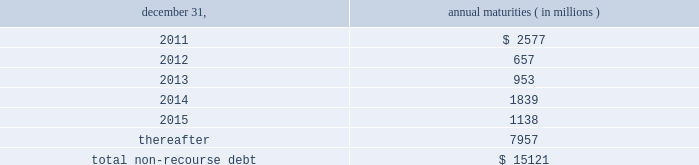The aes corporation notes to consolidated financial statements 2014 ( continued ) december 31 , 2010 , 2009 , and 2008 ( 3 ) multilateral loans include loans funded and guaranteed by bilaterals , multilaterals , development banks and other similar institutions .
( 4 ) non-recourse debt of $ 708 million as of december 31 , 2009 was excluded from non-recourse debt and included in current and long-term liabilities of held for sale and discontinued businesses in the accompanying consolidated balance sheets .
Non-recourse debt as of december 31 , 2010 is scheduled to reach maturity as set forth in the table below : december 31 , annual maturities ( in millions ) .
As of december 31 , 2010 , aes subsidiaries with facilities under construction had a total of approximately $ 432 million of committed but unused credit facilities available to fund construction and other related costs .
Excluding these facilities under construction , aes subsidiaries had approximately $ 893 million in a number of available but unused committed revolving credit lines to support their working capital , debt service reserves and other business needs .
These credit lines can be used in one or more of the following ways : solely for borrowings ; solely for letters of credit ; or a combination of these uses .
The weighted average interest rate on borrowings from these facilities was 3.24% ( 3.24 % ) at december 31 , 2010 .
Non-recourse debt covenants , restrictions and defaults the terms of the company 2019s non-recourse debt include certain financial and non-financial covenants .
These covenants are limited to subsidiary activity and vary among the subsidiaries .
These covenants may include but are not limited to maintenance of certain reserves , minimum levels of working capital and limitations on incurring additional indebtedness .
Compliance with certain covenants may not be objectively determinable .
As of december 31 , 2010 and 2009 , approximately $ 803 million and $ 653 million , respectively , of restricted cash was maintained in accordance with certain covenants of the non-recourse debt agreements , and these amounts were included within 201crestricted cash 201d and 201cdebt service reserves and other deposits 201d in the accompanying consolidated balance sheets .
Various lender and governmental provisions restrict the ability of certain of the company 2019s subsidiaries to transfer their net assets to the parent company .
Such restricted net assets of subsidiaries amounted to approximately $ 5.4 billion at december 31 , 2010. .
What percentage of non-recourse debt is current as of december 31 , 2010? 
Computations: (2577 / 15121)
Answer: 0.17043. 